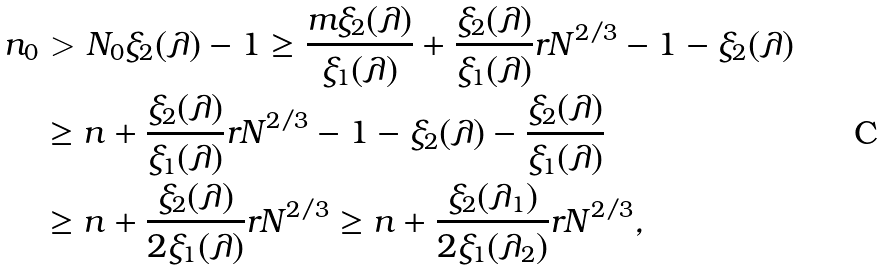Convert formula to latex. <formula><loc_0><loc_0><loc_500><loc_500>n _ { 0 } & > N _ { 0 } \xi _ { 2 } ( \lambda ) - 1 \geq \frac { m \xi _ { 2 } ( \lambda ) } { \xi _ { 1 } ( \lambda ) } + \frac { \xi _ { 2 } ( \lambda ) } { \xi _ { 1 } ( \lambda ) } r N ^ { 2 / 3 } - 1 - \xi _ { 2 } ( \lambda ) \\ & \geq n + \frac { \xi _ { 2 } ( \lambda ) } { \xi _ { 1 } ( \lambda ) } r N ^ { 2 / 3 } - 1 - \xi _ { 2 } ( \lambda ) - \frac { \xi _ { 2 } ( \lambda ) } { \xi _ { 1 } ( \lambda ) } \\ & \geq n + \frac { \xi _ { 2 } ( \lambda ) } { 2 \xi _ { 1 } ( \lambda ) } r N ^ { 2 / 3 } \geq n + \frac { \xi _ { 2 } ( \lambda _ { 1 } ) } { 2 \xi _ { 1 } ( \lambda _ { 2 } ) } r N ^ { 2 / 3 } ,</formula> 